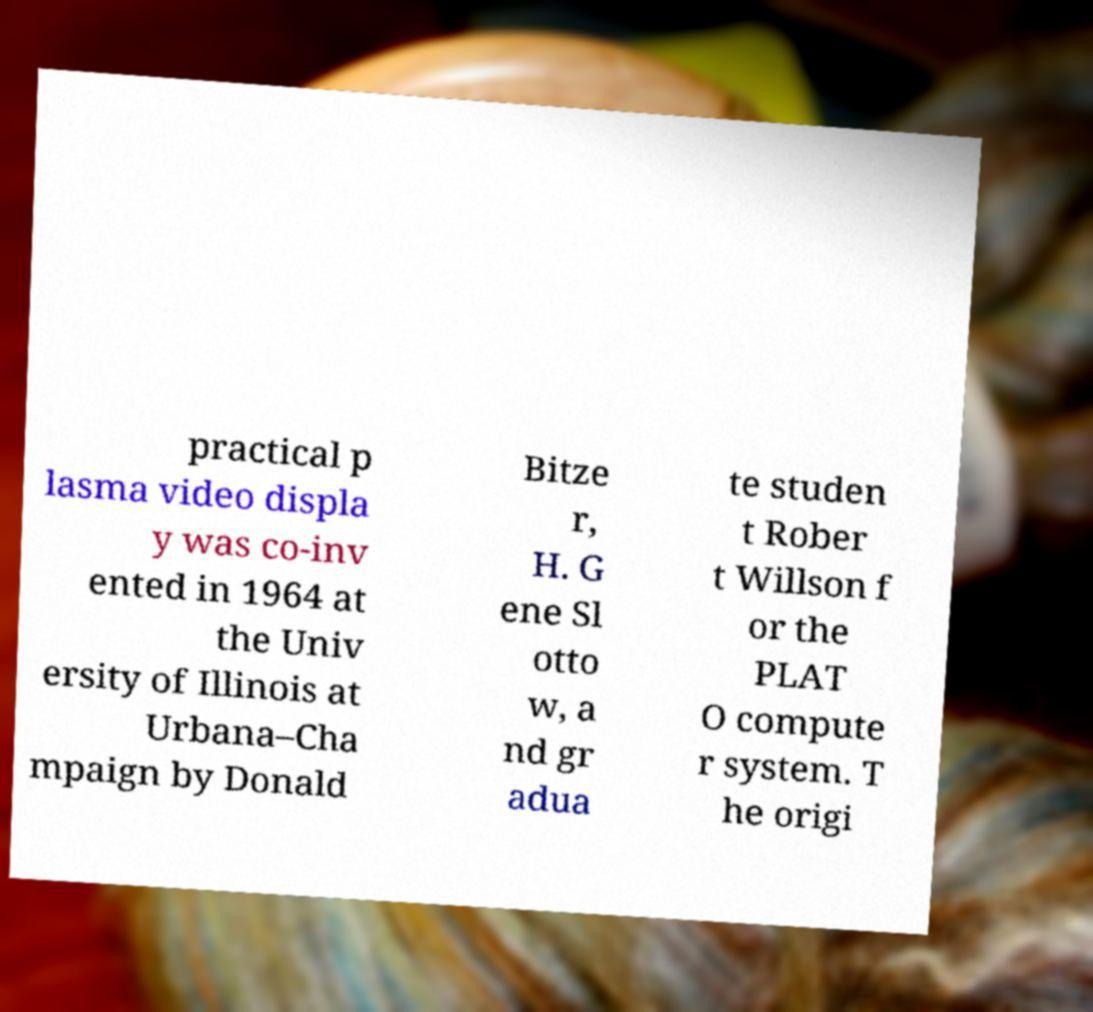There's text embedded in this image that I need extracted. Can you transcribe it verbatim? practical p lasma video displa y was co-inv ented in 1964 at the Univ ersity of Illinois at Urbana–Cha mpaign by Donald Bitze r, H. G ene Sl otto w, a nd gr adua te studen t Rober t Willson f or the PLAT O compute r system. T he origi 